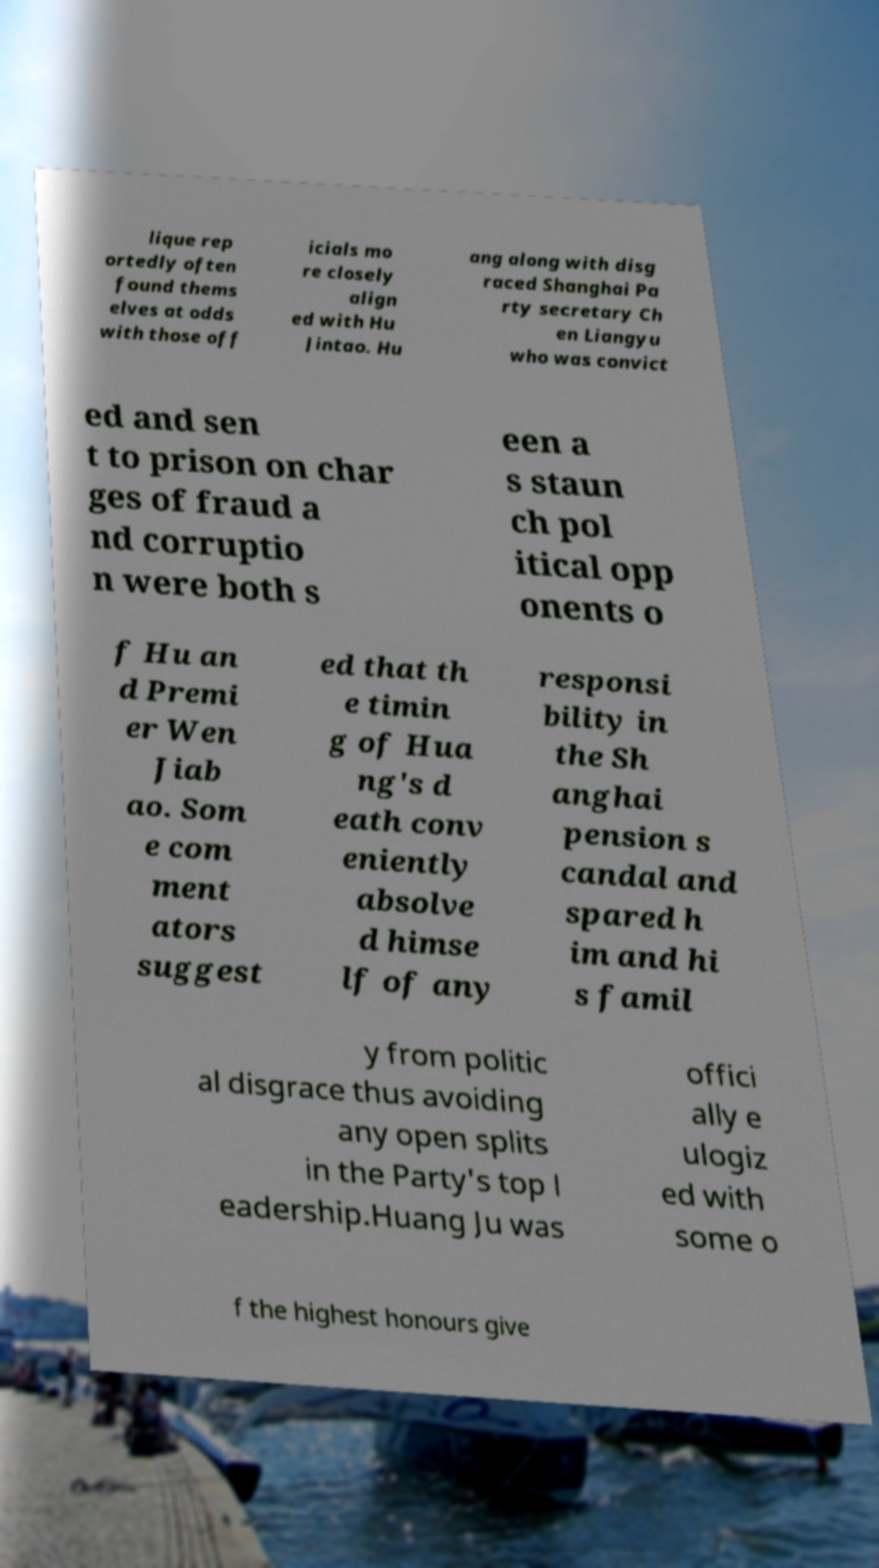For documentation purposes, I need the text within this image transcribed. Could you provide that? lique rep ortedly often found thems elves at odds with those off icials mo re closely align ed with Hu Jintao. Hu ang along with disg raced Shanghai Pa rty secretary Ch en Liangyu who was convict ed and sen t to prison on char ges of fraud a nd corruptio n were both s een a s staun ch pol itical opp onents o f Hu an d Premi er Wen Jiab ao. Som e com ment ators suggest ed that th e timin g of Hua ng's d eath conv eniently absolve d himse lf of any responsi bility in the Sh anghai pension s candal and spared h im and hi s famil y from politic al disgrace thus avoiding any open splits in the Party's top l eadership.Huang Ju was offici ally e ulogiz ed with some o f the highest honours give 